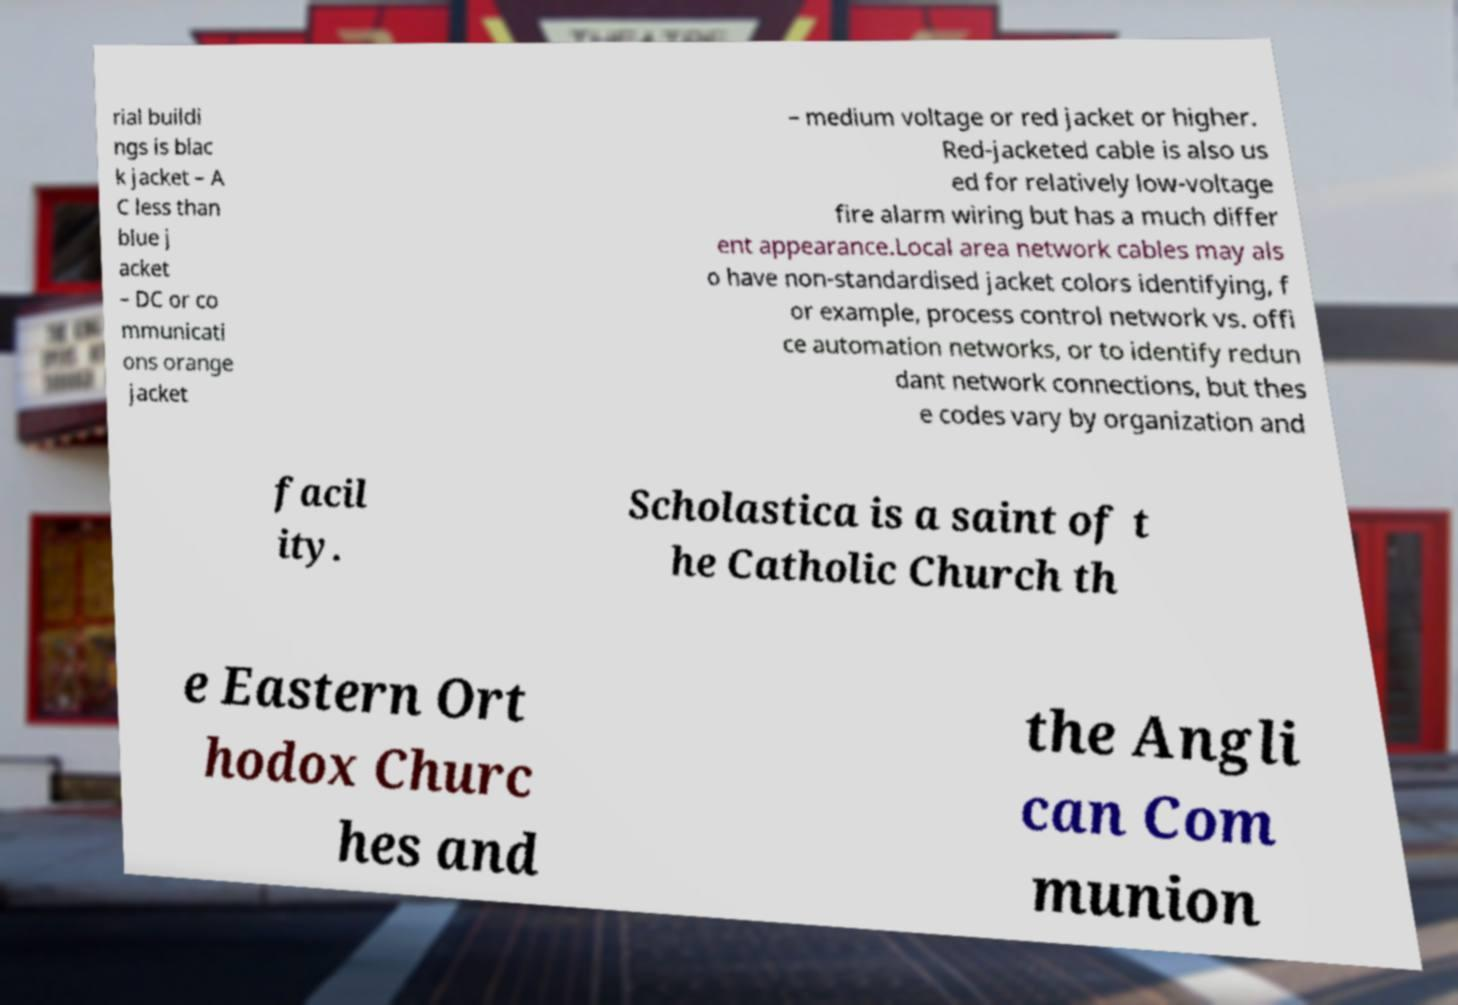Please identify and transcribe the text found in this image. rial buildi ngs is blac k jacket – A C less than blue j acket – DC or co mmunicati ons orange jacket – medium voltage or red jacket or higher. Red-jacketed cable is also us ed for relatively low-voltage fire alarm wiring but has a much differ ent appearance.Local area network cables may als o have non-standardised jacket colors identifying, f or example, process control network vs. offi ce automation networks, or to identify redun dant network connections, but thes e codes vary by organization and facil ity. Scholastica is a saint of t he Catholic Church th e Eastern Ort hodox Churc hes and the Angli can Com munion 